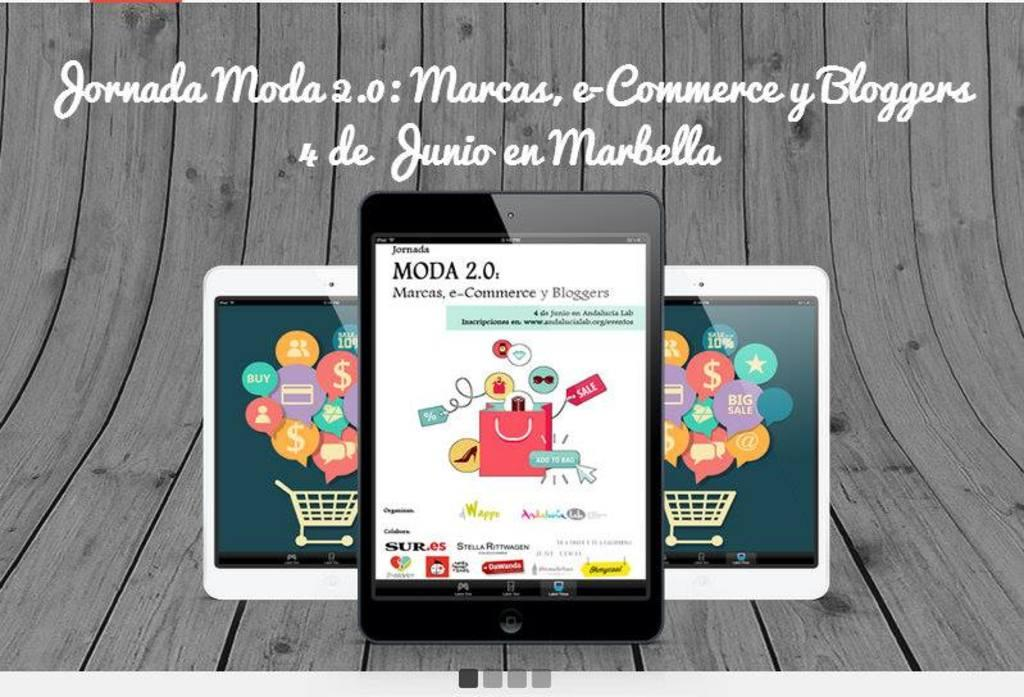<image>
Describe the image concisely. A tablet says Moda 2.0 at the top and is with two other tablets. 